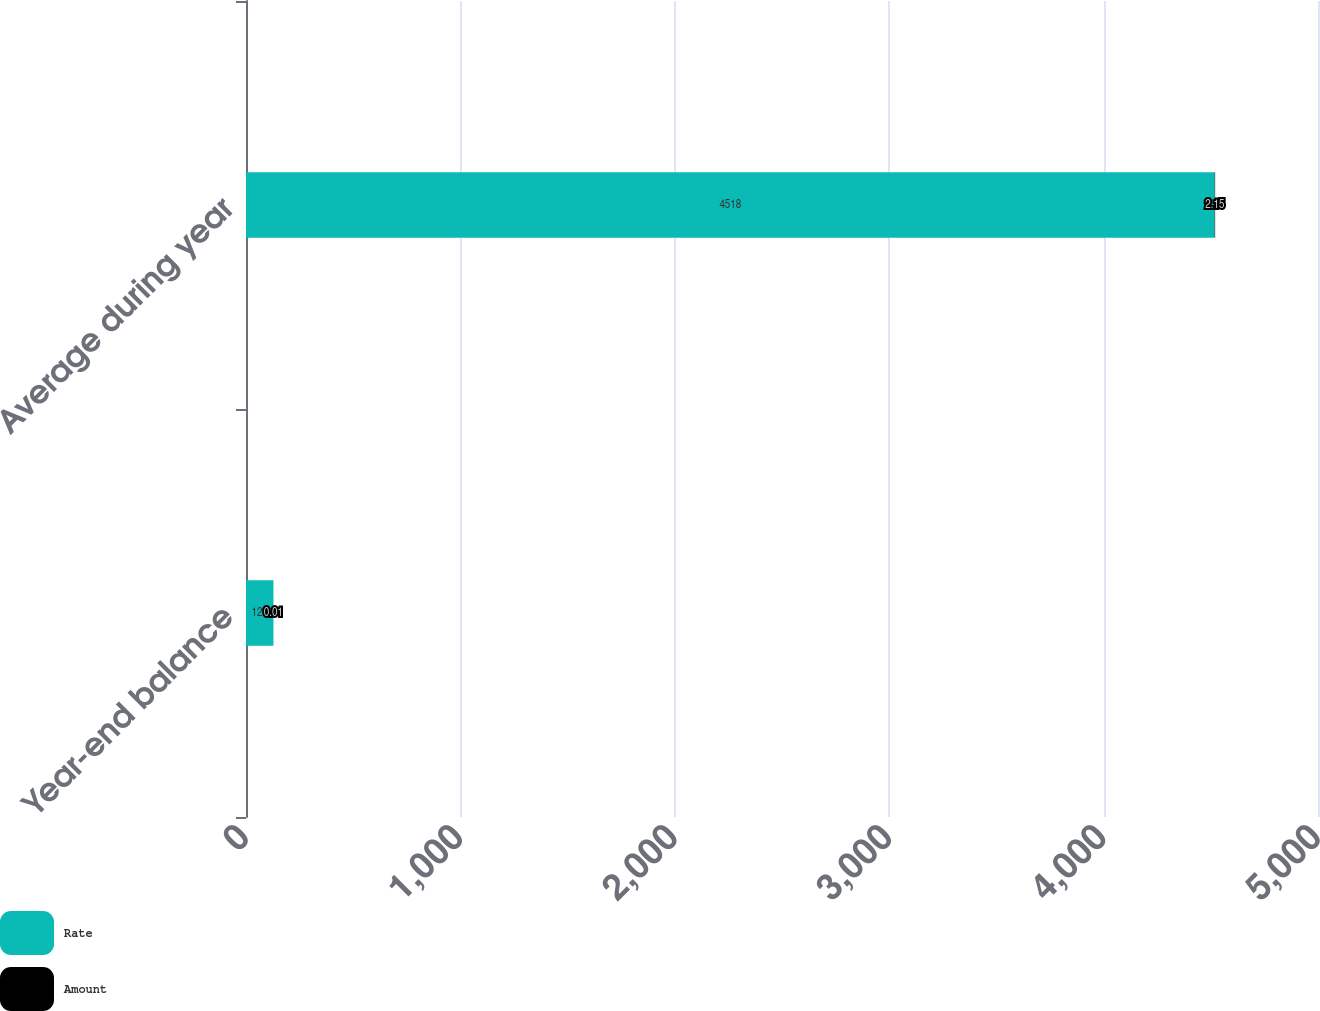<chart> <loc_0><loc_0><loc_500><loc_500><stacked_bar_chart><ecel><fcel>Year-end balance<fcel>Average during year<nl><fcel>Rate<fcel>128<fcel>4518<nl><fcel>Amount<fcel>0.01<fcel>2.15<nl></chart> 